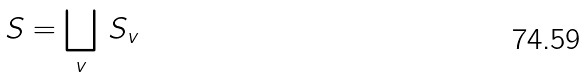<formula> <loc_0><loc_0><loc_500><loc_500>S = \bigsqcup _ { v } \, S _ { v }</formula> 